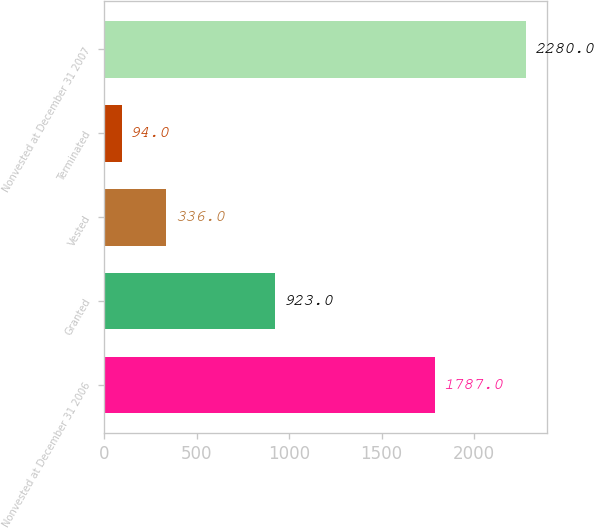Convert chart to OTSL. <chart><loc_0><loc_0><loc_500><loc_500><bar_chart><fcel>Nonvested at December 31 2006<fcel>Granted<fcel>Vested<fcel>Terminated<fcel>Nonvested at December 31 2007<nl><fcel>1787<fcel>923<fcel>336<fcel>94<fcel>2280<nl></chart> 